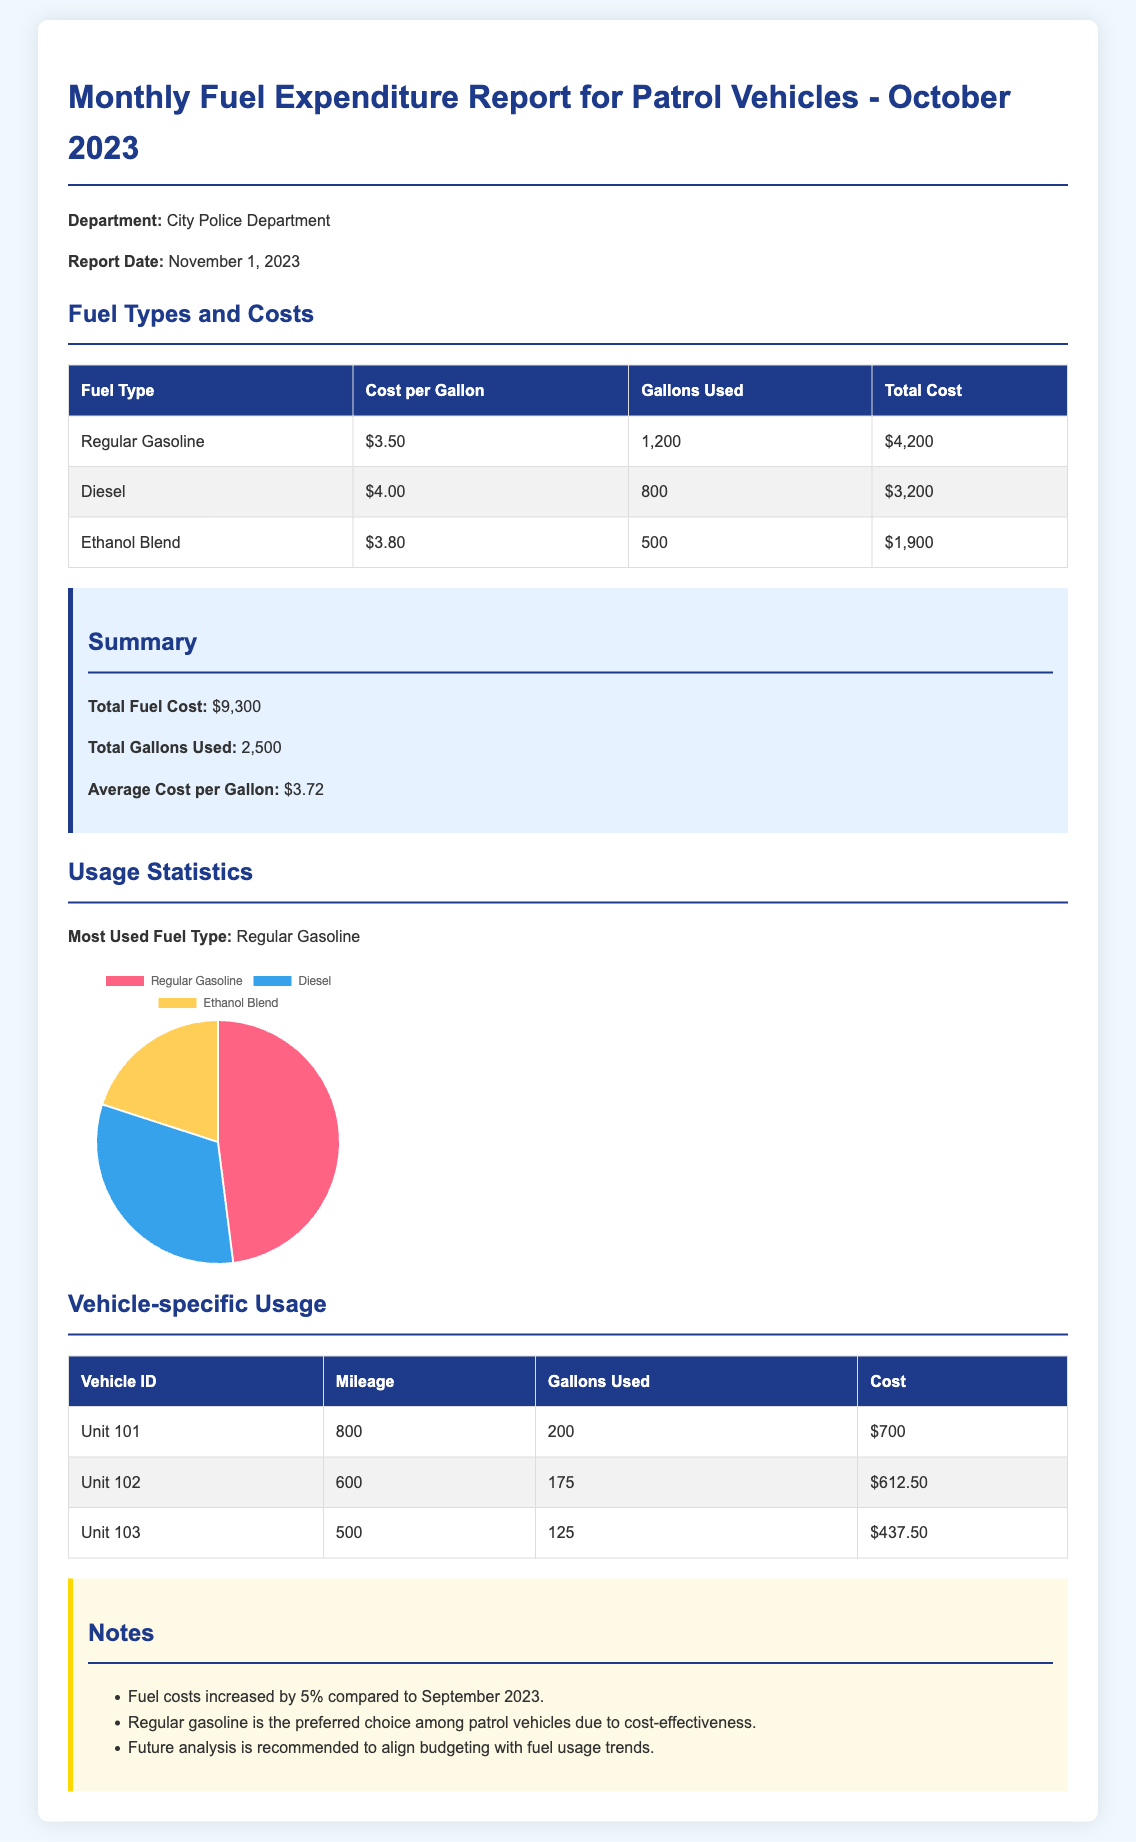what is the total fuel cost? The total fuel cost is provided in the summary section, which is $9,300.
Answer: $9,300 how many gallons of Regular Gasoline were used? The gallons used for Regular Gasoline is found in the fuel types table, which shows 1,200 gallons.
Answer: 1,200 what is the cost per gallon of Diesel? The cost per gallon of Diesel is stated in the fuel types table as $4.00.
Answer: $4.00 which fuel type had the highest usage? The information in the usage statistics section indicates that Regular Gasoline had the most usage.
Answer: Regular Gasoline how many gallons of Ethanol Blend were used? The gallons used for Ethanol Blend can be found in the fuel types table, which lists 500 gallons used.
Answer: 500 what is the total miles driven by Unit 101? The mileage for Unit 101 is recorded in the vehicle-specific usage table, which shows 800 miles.
Answer: 800 what was the increase in fuel costs compared to September 2023? The notes section mentions that fuel costs increased by 5% compared to the previous month.
Answer: 5% how many gallons were used in total? The total gallons used is provided in the summary section, which is 2,500 gallons.
Answer: 2,500 who is the department issuing the report? The department is mentioned at the beginning of the report as the City Police Department.
Answer: City Police Department 